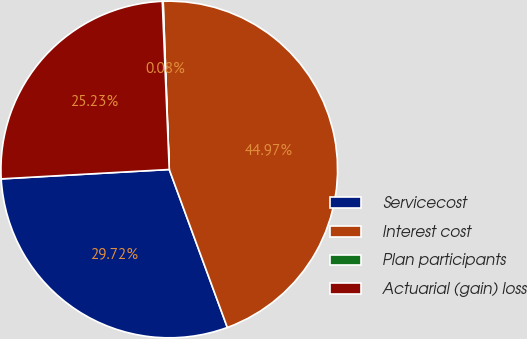<chart> <loc_0><loc_0><loc_500><loc_500><pie_chart><fcel>Servicecost<fcel>Interest cost<fcel>Plan participants<fcel>Actuarial (gain) loss<nl><fcel>29.72%<fcel>44.97%<fcel>0.08%<fcel>25.23%<nl></chart> 